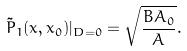<formula> <loc_0><loc_0><loc_500><loc_500>\tilde { P } _ { 1 } ( x , x _ { 0 } ) | _ { D = 0 } = \sqrt { \frac { B A _ { 0 } } { A } } .</formula> 